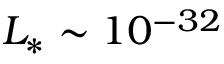<formula> <loc_0><loc_0><loc_500><loc_500>L _ { * } \sim 1 0 ^ { - 3 2 }</formula> 